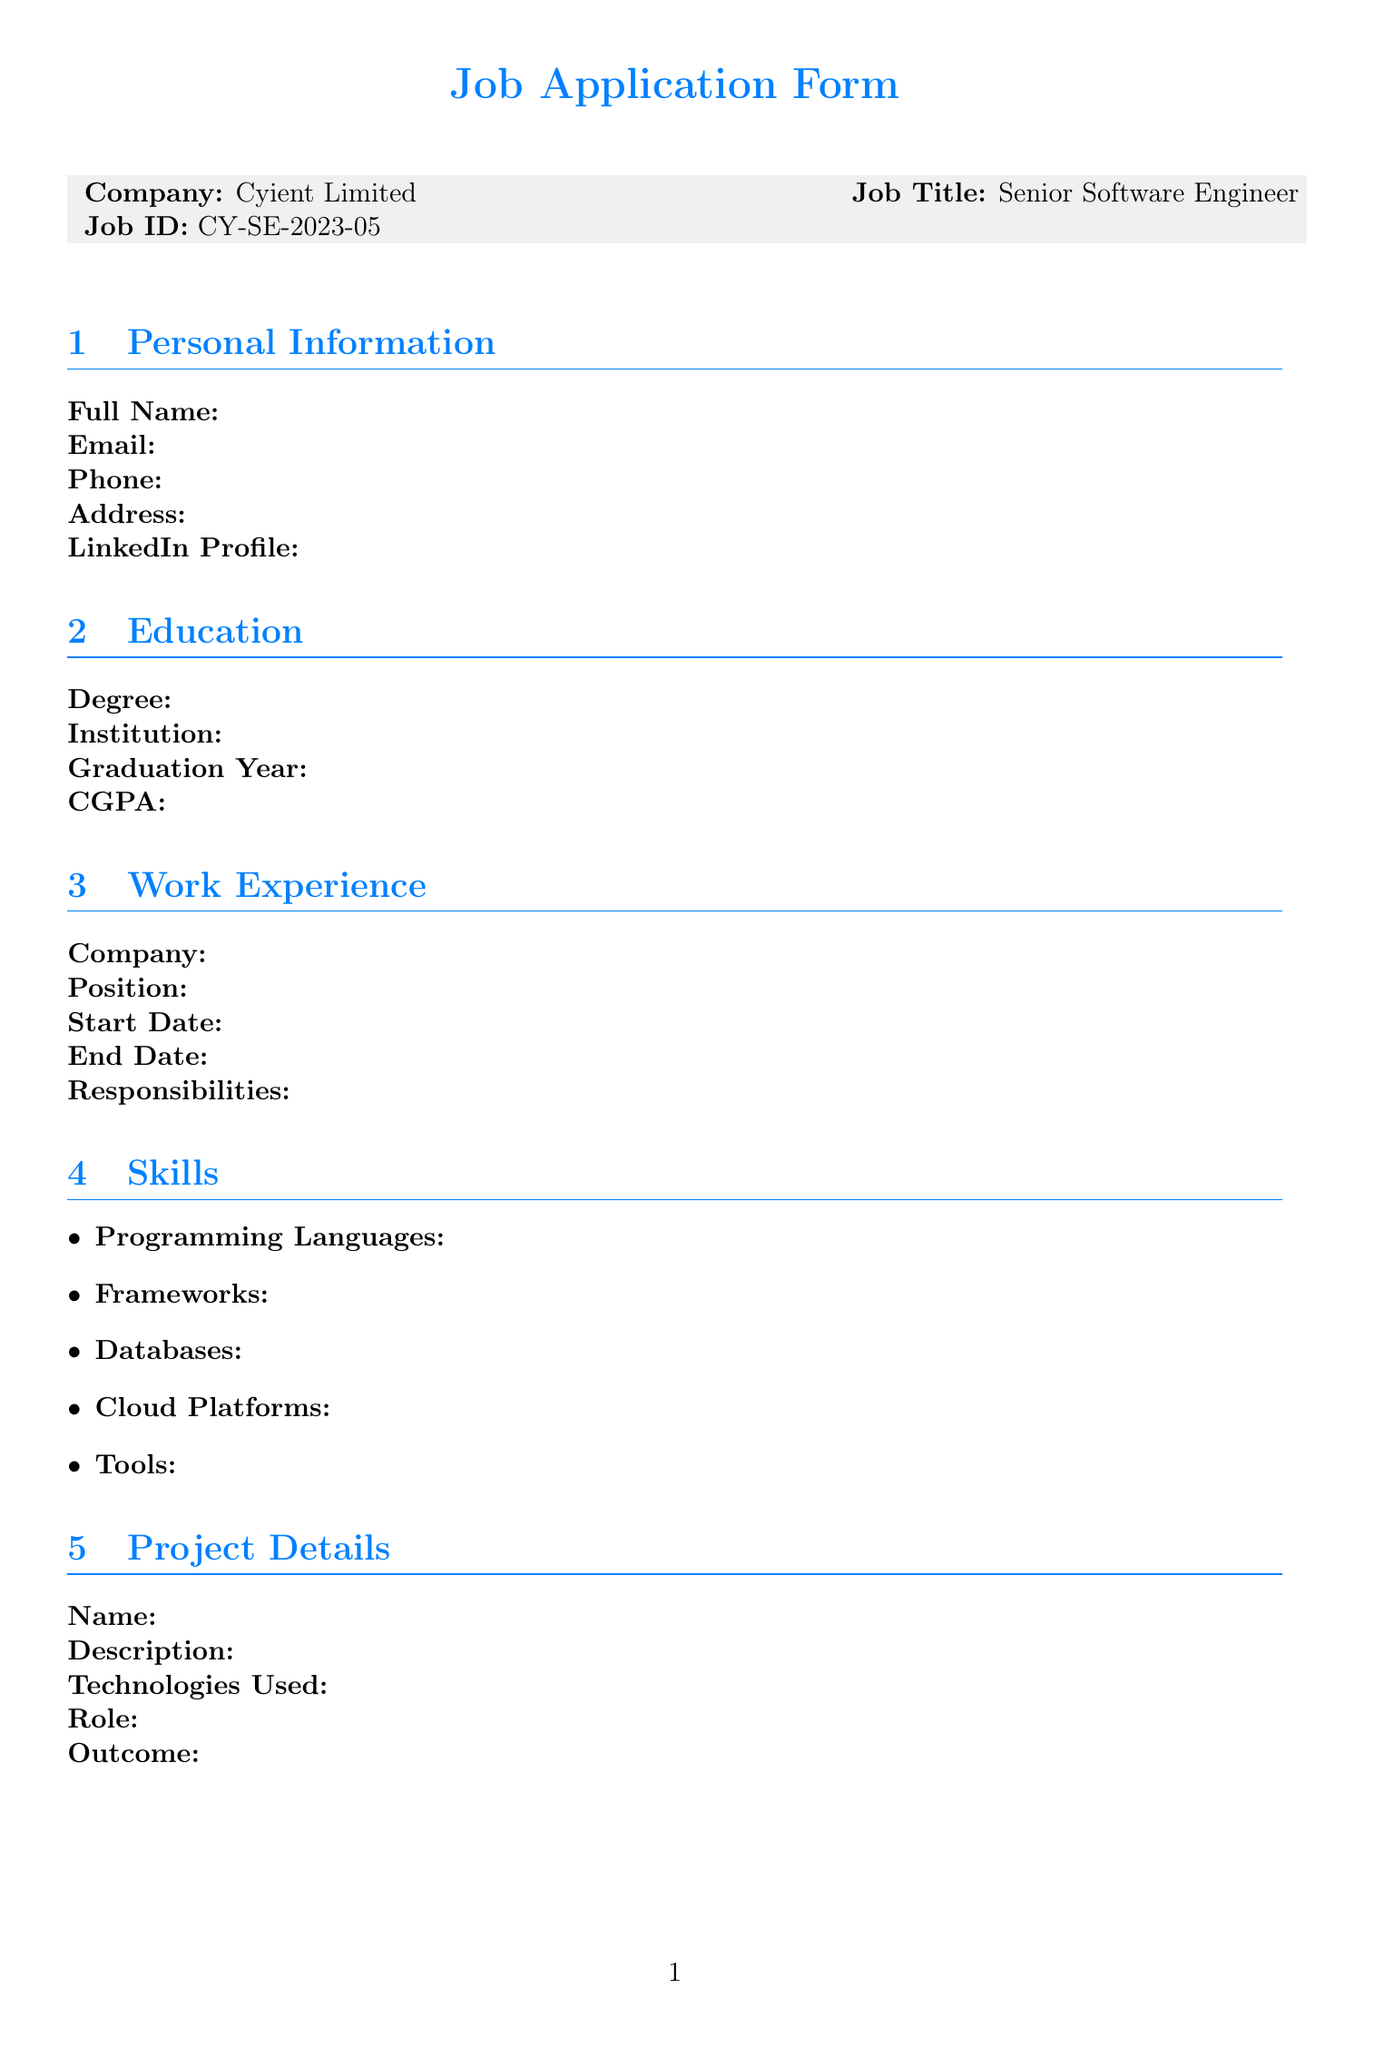What is the company name? The company name is provided in the document under "Company:", which is Cyient Limited.
Answer: Cyient Limited What is the job title? The job title is listed under "Job Title:" and it states Senior Software Engineer.
Answer: Senior Software Engineer What is the job ID? The job ID appears under "Job ID:" and it is CY-SE-2023-05.
Answer: CY-SE-2023-05 What information is required for personal details? Personal details require Full Name, Email, Phone, Address, and LinkedIn Profile, as shown in the document.
Answer: Full Name, Email, Phone, Address, LinkedIn Profile Is a declaration included in this application form? The document contains a section titled "Declaration" confirming the truth of the provided information, indicating its inclusion.
Answer: Yes How many sections are in the application form? The document has a total of eight sections, including Personal Information, Education, Work Experience, Skills, Project Details, Certifications, Language Proficiency, Additional Questions, References, and Declaration.
Answer: Eight What language proficiency is mentioned? The document includes a section called "Language Proficiency." However, it doesn't specify any language within the data provided.
Answer: Not specified Are references required in the application form? Yes, there is a section titled "References" which indicates that references are required in the document.
Answer: Yes What additional question asks about management methodologies? One of the additional questions asks if the applicant is familiar with Agile development methodologies.
Answer: Agile development methodologies 